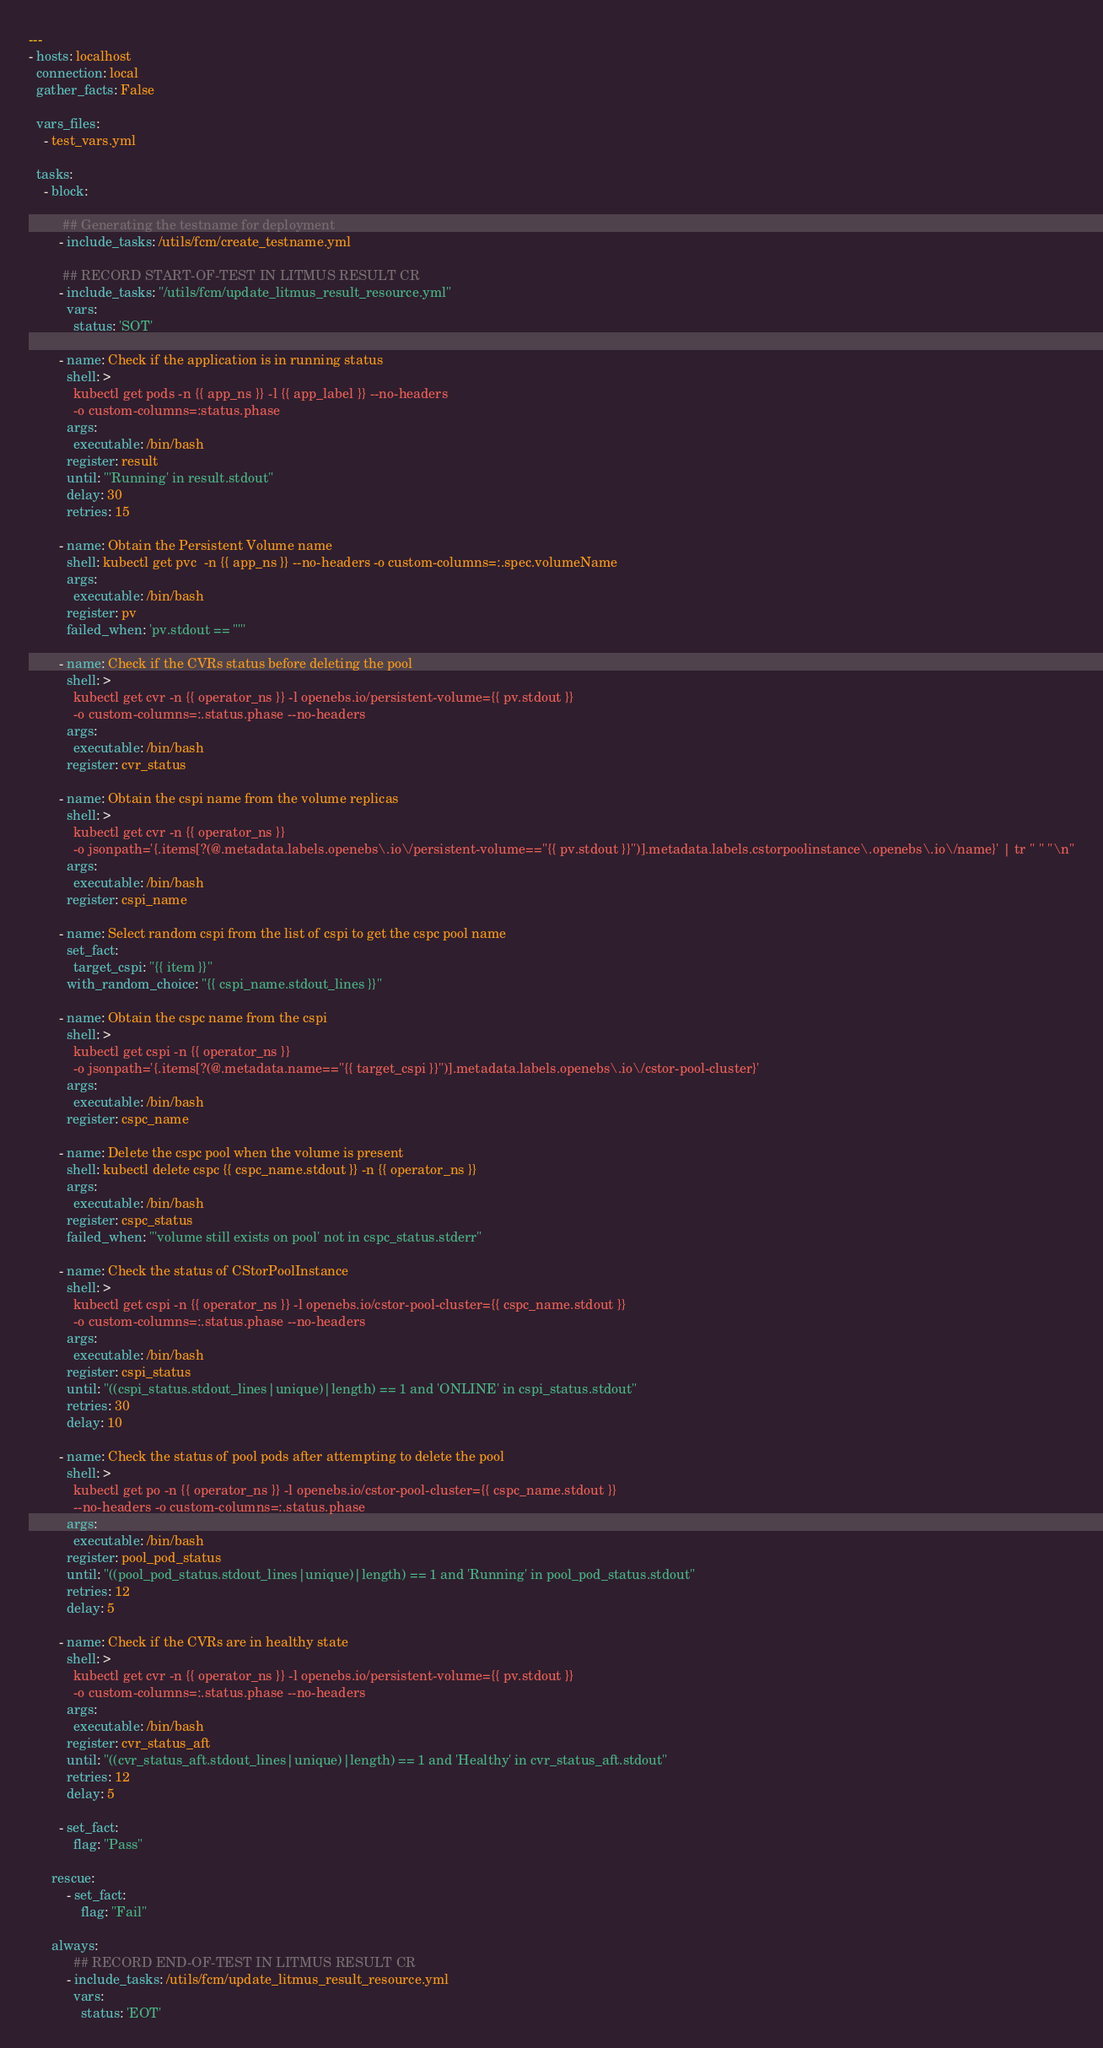Convert code to text. <code><loc_0><loc_0><loc_500><loc_500><_YAML_>---
- hosts: localhost
  connection: local
  gather_facts: False

  vars_files:
    - test_vars.yml

  tasks:
    - block:

         ## Generating the testname for deployment
        - include_tasks: /utils/fcm/create_testname.yml

         ## RECORD START-OF-TEST IN LITMUS RESULT CR
        - include_tasks: "/utils/fcm/update_litmus_result_resource.yml"
          vars:
            status: 'SOT'

        - name: Check if the application is in running status
          shell: >
            kubectl get pods -n {{ app_ns }} -l {{ app_label }} --no-headers
            -o custom-columns=:status.phase
          args:
            executable: /bin/bash
          register: result
          until: "'Running' in result.stdout"
          delay: 30
          retries: 15

        - name: Obtain the Persistent Volume name
          shell: kubectl get pvc  -n {{ app_ns }} --no-headers -o custom-columns=:.spec.volumeName
          args:
            executable: /bin/bash
          register: pv
          failed_when: 'pv.stdout == ""'

        - name: Check if the CVRs status before deleting the pool
          shell: >
            kubectl get cvr -n {{ operator_ns }} -l openebs.io/persistent-volume={{ pv.stdout }}
            -o custom-columns=:.status.phase --no-headers
          args:
            executable: /bin/bash
          register: cvr_status

        - name: Obtain the cspi name from the volume replicas
          shell: >
            kubectl get cvr -n {{ operator_ns }}
            -o jsonpath='{.items[?(@.metadata.labels.openebs\.io\/persistent-volume=="{{ pv.stdout }}")].metadata.labels.cstorpoolinstance\.openebs\.io\/name}' | tr " " "\n"
          args:
            executable: /bin/bash
          register: cspi_name

        - name: Select random cspi from the list of cspi to get the cspc pool name
          set_fact:
            target_cspi: "{{ item }}"
          with_random_choice: "{{ cspi_name.stdout_lines }}"

        - name: Obtain the cspc name from the cspi
          shell: >
            kubectl get cspi -n {{ operator_ns }}
            -o jsonpath='{.items[?(@.metadata.name=="{{ target_cspi }}")].metadata.labels.openebs\.io\/cstor-pool-cluster}'
          args:
            executable: /bin/bash
          register: cspc_name

        - name: Delete the cspc pool when the volume is present
          shell: kubectl delete cspc {{ cspc_name.stdout }} -n {{ operator_ns }}
          args:
            executable: /bin/bash
          register: cspc_status
          failed_when: "'volume still exists on pool' not in cspc_status.stderr"

        - name: Check the status of CStorPoolInstance
          shell: >
            kubectl get cspi -n {{ operator_ns }} -l openebs.io/cstor-pool-cluster={{ cspc_name.stdout }}
            -o custom-columns=:.status.phase --no-headers
          args:
            executable: /bin/bash
          register: cspi_status
          until: "((cspi_status.stdout_lines|unique)|length) == 1 and 'ONLINE' in cspi_status.stdout"
          retries: 30
          delay: 10

        - name: Check the status of pool pods after attempting to delete the pool
          shell: >
            kubectl get po -n {{ operator_ns }} -l openebs.io/cstor-pool-cluster={{ cspc_name.stdout }}
            --no-headers -o custom-columns=:.status.phase
          args:
            executable: /bin/bash
          register: pool_pod_status
          until: "((pool_pod_status.stdout_lines|unique)|length) == 1 and 'Running' in pool_pod_status.stdout"
          retries: 12
          delay: 5

        - name: Check if the CVRs are in healthy state
          shell: >
            kubectl get cvr -n {{ operator_ns }} -l openebs.io/persistent-volume={{ pv.stdout }}
            -o custom-columns=:.status.phase --no-headers
          args:
            executable: /bin/bash
          register: cvr_status_aft
          until: "((cvr_status_aft.stdout_lines|unique)|length) == 1 and 'Healthy' in cvr_status_aft.stdout"
          retries: 12
          delay: 5

        - set_fact:
            flag: "Pass"

      rescue:
          - set_fact:
              flag: "Fail"

      always:
            ## RECORD END-OF-TEST IN LITMUS RESULT CR
          - include_tasks: /utils/fcm/update_litmus_result_resource.yml
            vars:
              status: 'EOT'
</code> 